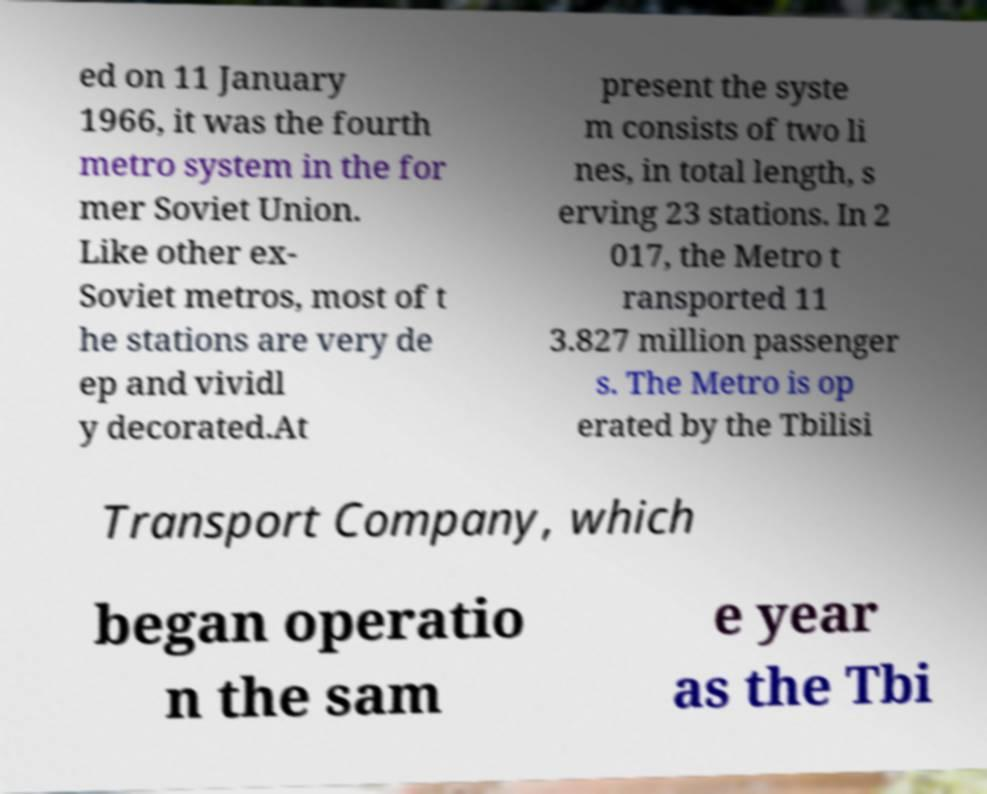Could you extract and type out the text from this image? ed on 11 January 1966, it was the fourth metro system in the for mer Soviet Union. Like other ex- Soviet metros, most of t he stations are very de ep and vividl y decorated.At present the syste m consists of two li nes, in total length, s erving 23 stations. In 2 017, the Metro t ransported 11 3.827 million passenger s. The Metro is op erated by the Tbilisi Transport Company, which began operatio n the sam e year as the Tbi 